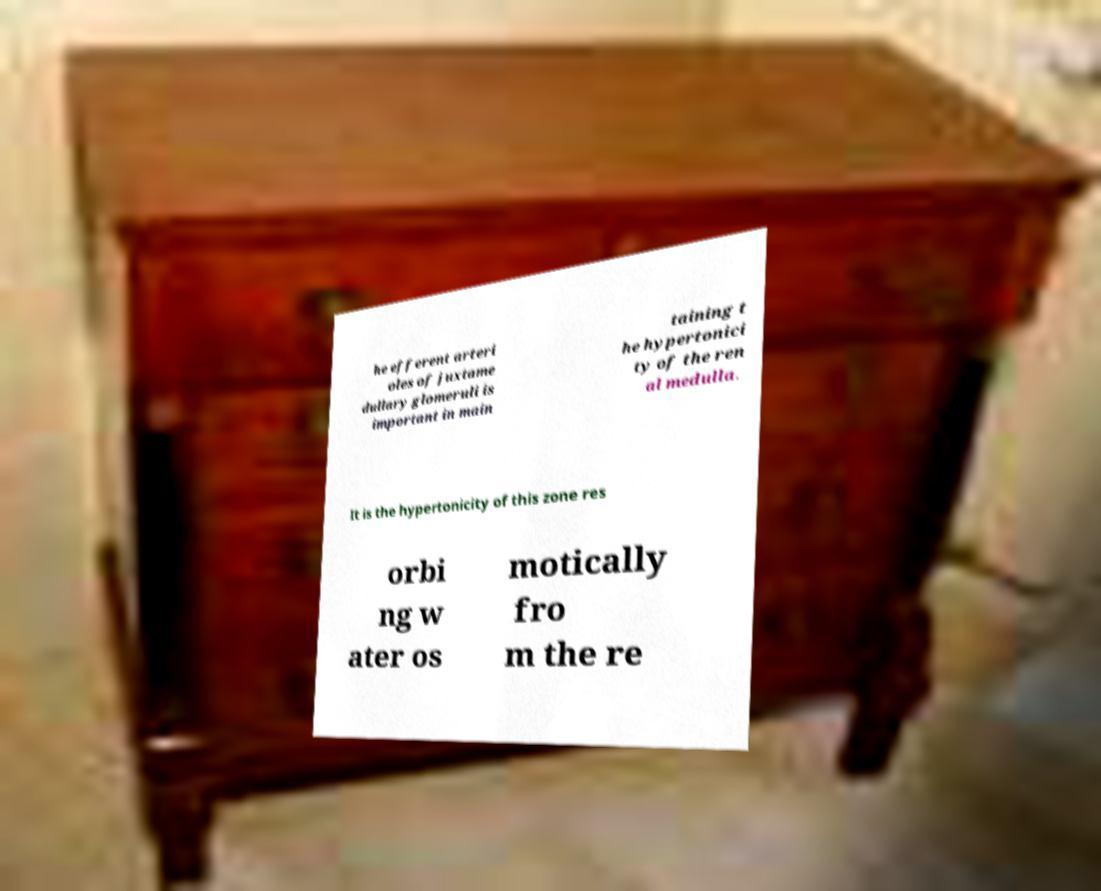What messages or text are displayed in this image? I need them in a readable, typed format. he efferent arteri oles of juxtame dullary glomeruli is important in main taining t he hypertonici ty of the ren al medulla. It is the hypertonicity of this zone res orbi ng w ater os motically fro m the re 